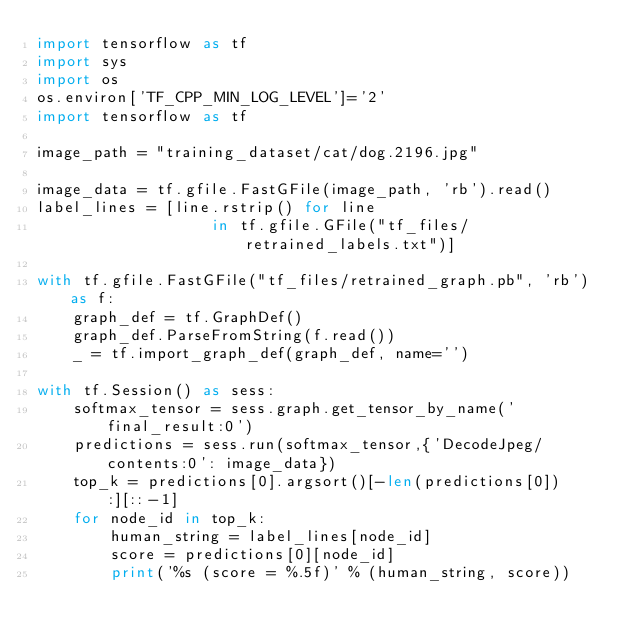<code> <loc_0><loc_0><loc_500><loc_500><_Python_>import tensorflow as tf
import sys
import os
os.environ['TF_CPP_MIN_LOG_LEVEL']='2'
import tensorflow as tf

image_path = "training_dataset/cat/dog.2196.jpg"

image_data = tf.gfile.FastGFile(image_path, 'rb').read()
label_lines = [line.rstrip() for line
                   in tf.gfile.GFile("tf_files/retrained_labels.txt")]

with tf.gfile.FastGFile("tf_files/retrained_graph.pb", 'rb') as f:
    graph_def = tf.GraphDef()
    graph_def.ParseFromString(f.read())
    _ = tf.import_graph_def(graph_def, name='')

with tf.Session() as sess:
    softmax_tensor = sess.graph.get_tensor_by_name('final_result:0')
    predictions = sess.run(softmax_tensor,{'DecodeJpeg/contents:0': image_data})
    top_k = predictions[0].argsort()[-len(predictions[0]):][::-1]
    for node_id in top_k:
        human_string = label_lines[node_id]
        score = predictions[0][node_id]
        print('%s (score = %.5f)' % (human_string, score))</code> 